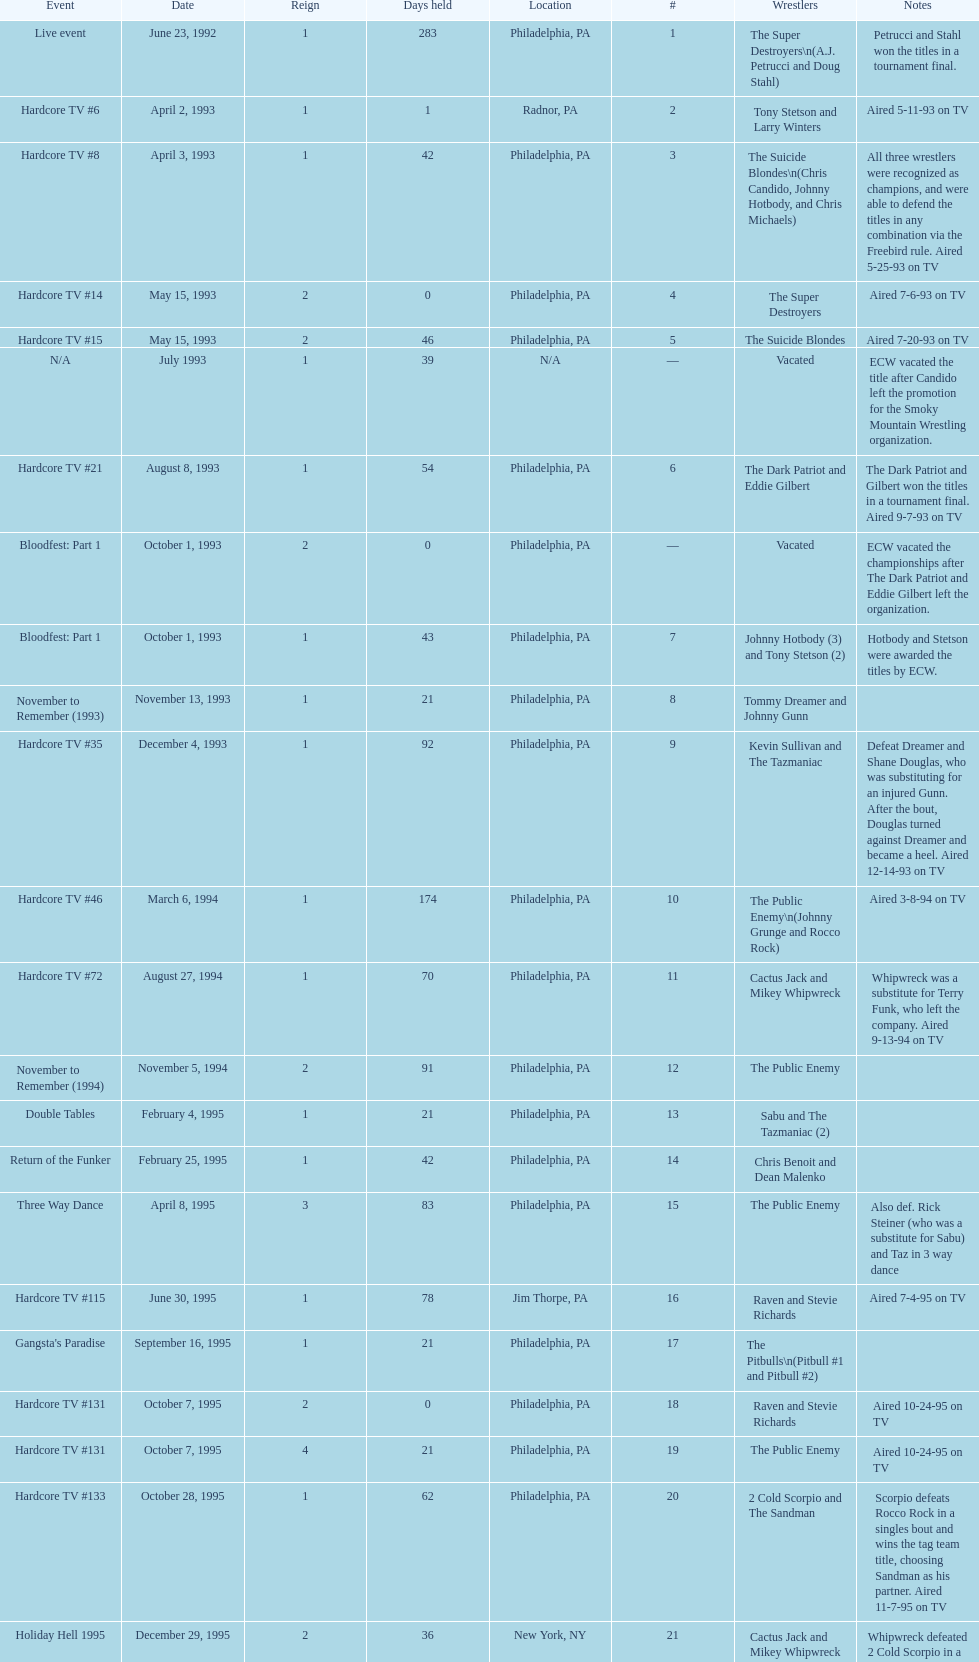What is the next event after hardcore tv #15? Hardcore TV #21. 